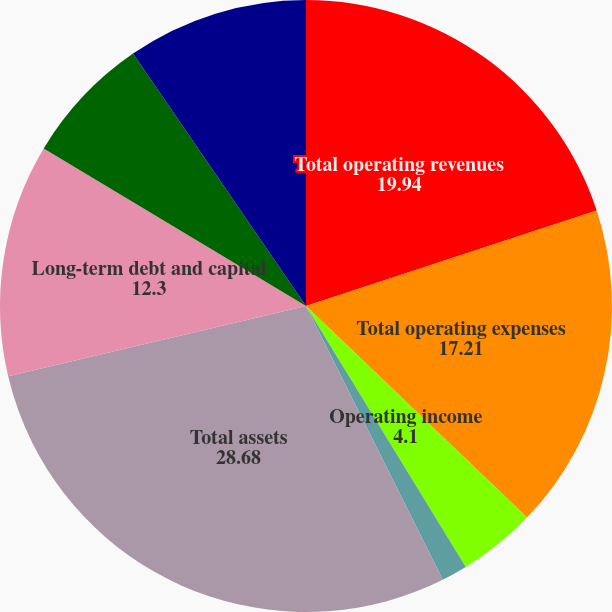Convert chart. <chart><loc_0><loc_0><loc_500><loc_500><pie_chart><fcel>Total operating revenues<fcel>Total operating expenses<fcel>Operating income<fcel>Net income (loss)<fcel>Total assets<fcel>Long-term debt and capital<fcel>Pension and postretirement<fcel>Stockholder's equity (deficit)<nl><fcel>19.94%<fcel>17.21%<fcel>4.1%<fcel>1.37%<fcel>28.68%<fcel>12.3%<fcel>6.83%<fcel>9.56%<nl></chart> 